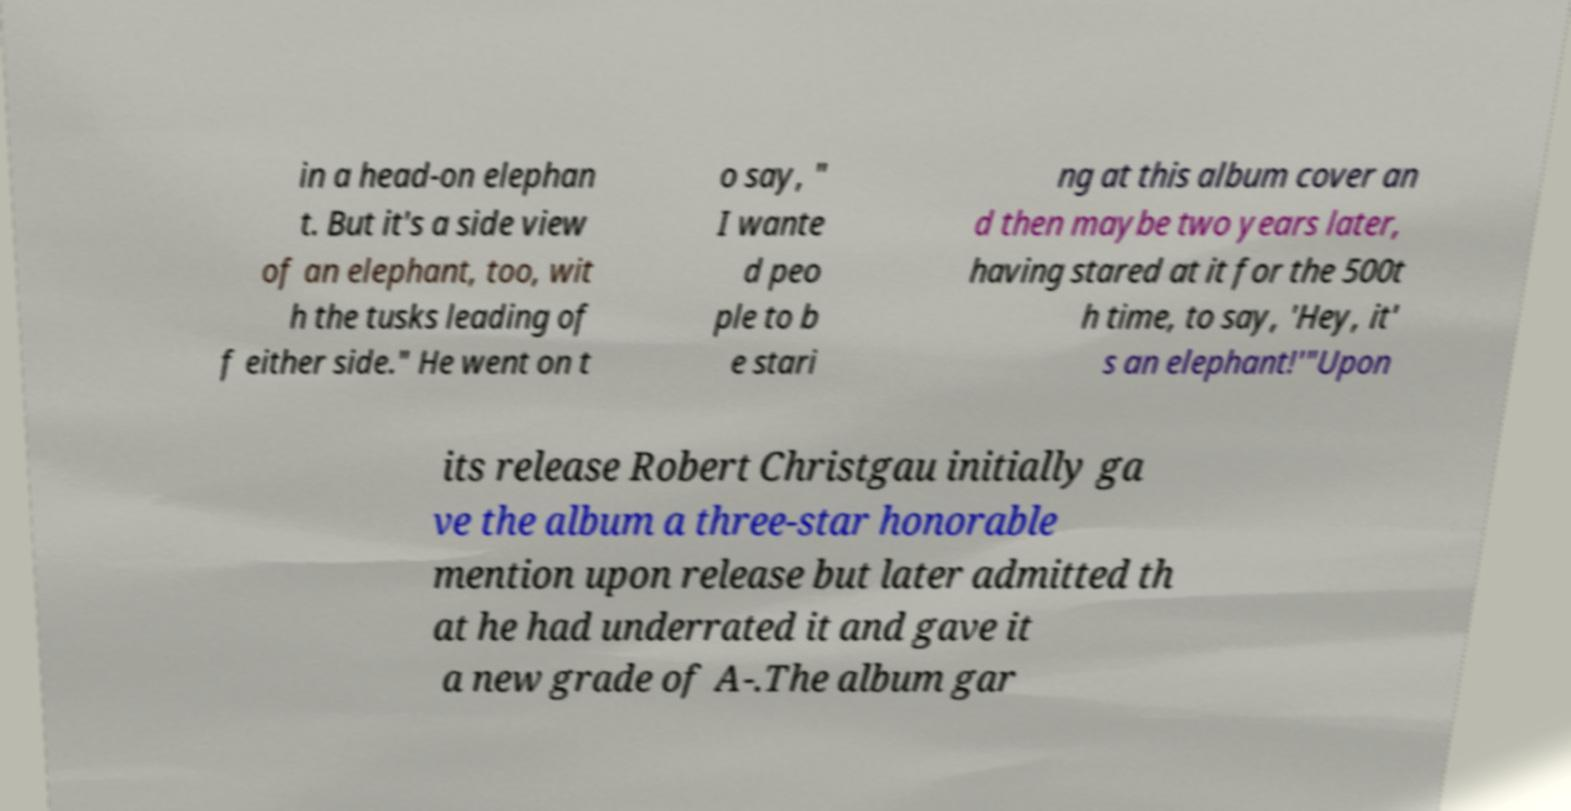There's text embedded in this image that I need extracted. Can you transcribe it verbatim? in a head-on elephan t. But it's a side view of an elephant, too, wit h the tusks leading of f either side." He went on t o say, " I wante d peo ple to b e stari ng at this album cover an d then maybe two years later, having stared at it for the 500t h time, to say, 'Hey, it' s an elephant!'"Upon its release Robert Christgau initially ga ve the album a three-star honorable mention upon release but later admitted th at he had underrated it and gave it a new grade of A-.The album gar 